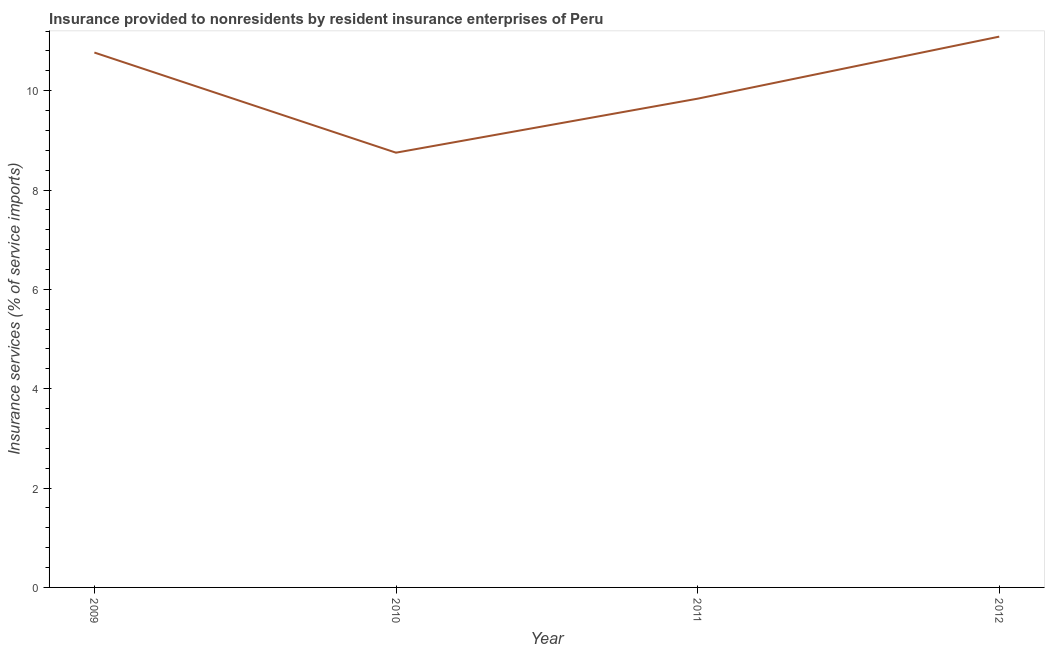What is the insurance and financial services in 2012?
Make the answer very short. 11.09. Across all years, what is the maximum insurance and financial services?
Offer a terse response. 11.09. Across all years, what is the minimum insurance and financial services?
Ensure brevity in your answer.  8.75. In which year was the insurance and financial services maximum?
Ensure brevity in your answer.  2012. What is the sum of the insurance and financial services?
Ensure brevity in your answer.  40.45. What is the difference between the insurance and financial services in 2009 and 2012?
Make the answer very short. -0.32. What is the average insurance and financial services per year?
Offer a terse response. 10.11. What is the median insurance and financial services?
Give a very brief answer. 10.3. In how many years, is the insurance and financial services greater than 7.6 %?
Make the answer very short. 4. Do a majority of the years between 2010 and 2011 (inclusive) have insurance and financial services greater than 9.2 %?
Your answer should be compact. No. What is the ratio of the insurance and financial services in 2009 to that in 2010?
Give a very brief answer. 1.23. Is the insurance and financial services in 2010 less than that in 2012?
Make the answer very short. Yes. Is the difference between the insurance and financial services in 2010 and 2012 greater than the difference between any two years?
Offer a very short reply. Yes. What is the difference between the highest and the second highest insurance and financial services?
Ensure brevity in your answer.  0.32. Is the sum of the insurance and financial services in 2009 and 2012 greater than the maximum insurance and financial services across all years?
Keep it short and to the point. Yes. What is the difference between the highest and the lowest insurance and financial services?
Give a very brief answer. 2.34. In how many years, is the insurance and financial services greater than the average insurance and financial services taken over all years?
Make the answer very short. 2. How many lines are there?
Your response must be concise. 1. What is the difference between two consecutive major ticks on the Y-axis?
Ensure brevity in your answer.  2. Are the values on the major ticks of Y-axis written in scientific E-notation?
Your response must be concise. No. Does the graph contain any zero values?
Offer a very short reply. No. Does the graph contain grids?
Give a very brief answer. No. What is the title of the graph?
Give a very brief answer. Insurance provided to nonresidents by resident insurance enterprises of Peru. What is the label or title of the Y-axis?
Give a very brief answer. Insurance services (% of service imports). What is the Insurance services (% of service imports) in 2009?
Ensure brevity in your answer.  10.77. What is the Insurance services (% of service imports) in 2010?
Give a very brief answer. 8.75. What is the Insurance services (% of service imports) of 2011?
Ensure brevity in your answer.  9.84. What is the Insurance services (% of service imports) of 2012?
Ensure brevity in your answer.  11.09. What is the difference between the Insurance services (% of service imports) in 2009 and 2010?
Provide a succinct answer. 2.02. What is the difference between the Insurance services (% of service imports) in 2009 and 2011?
Provide a succinct answer. 0.93. What is the difference between the Insurance services (% of service imports) in 2009 and 2012?
Keep it short and to the point. -0.32. What is the difference between the Insurance services (% of service imports) in 2010 and 2011?
Provide a succinct answer. -1.09. What is the difference between the Insurance services (% of service imports) in 2010 and 2012?
Provide a short and direct response. -2.34. What is the difference between the Insurance services (% of service imports) in 2011 and 2012?
Make the answer very short. -1.25. What is the ratio of the Insurance services (% of service imports) in 2009 to that in 2010?
Give a very brief answer. 1.23. What is the ratio of the Insurance services (% of service imports) in 2009 to that in 2011?
Make the answer very short. 1.09. What is the ratio of the Insurance services (% of service imports) in 2010 to that in 2011?
Your answer should be very brief. 0.89. What is the ratio of the Insurance services (% of service imports) in 2010 to that in 2012?
Offer a very short reply. 0.79. What is the ratio of the Insurance services (% of service imports) in 2011 to that in 2012?
Your answer should be compact. 0.89. 